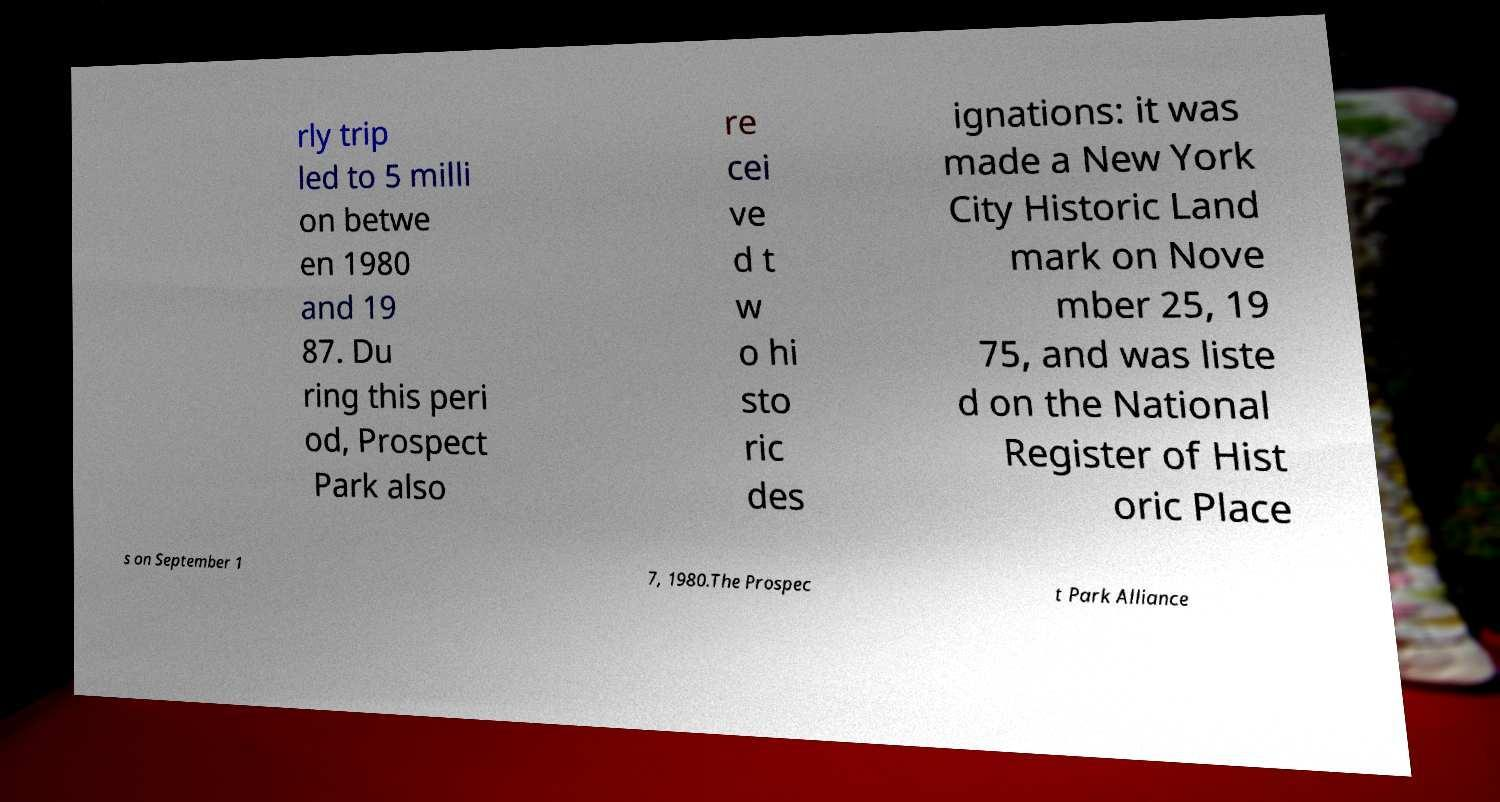There's text embedded in this image that I need extracted. Can you transcribe it verbatim? rly trip led to 5 milli on betwe en 1980 and 19 87. Du ring this peri od, Prospect Park also re cei ve d t w o hi sto ric des ignations: it was made a New York City Historic Land mark on Nove mber 25, 19 75, and was liste d on the National Register of Hist oric Place s on September 1 7, 1980.The Prospec t Park Alliance 